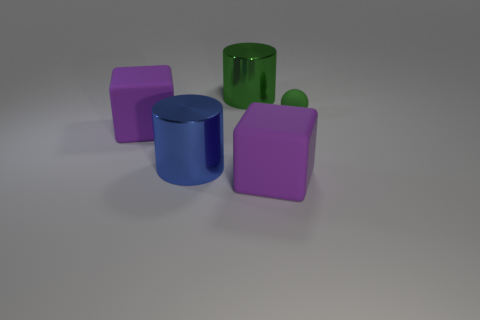Add 4 small purple matte balls. How many objects exist? 9 Subtract all green cylinders. How many cylinders are left? 1 Subtract 1 cylinders. How many cylinders are left? 1 Subtract all blue blocks. How many brown balls are left? 0 Subtract all spheres. How many objects are left? 4 Subtract all red cylinders. Subtract all yellow balls. How many cylinders are left? 2 Subtract all rubber spheres. Subtract all green balls. How many objects are left? 3 Add 2 large purple rubber things. How many large purple rubber things are left? 4 Add 2 small cyan rubber spheres. How many small cyan rubber spheres exist? 2 Subtract 1 green cylinders. How many objects are left? 4 